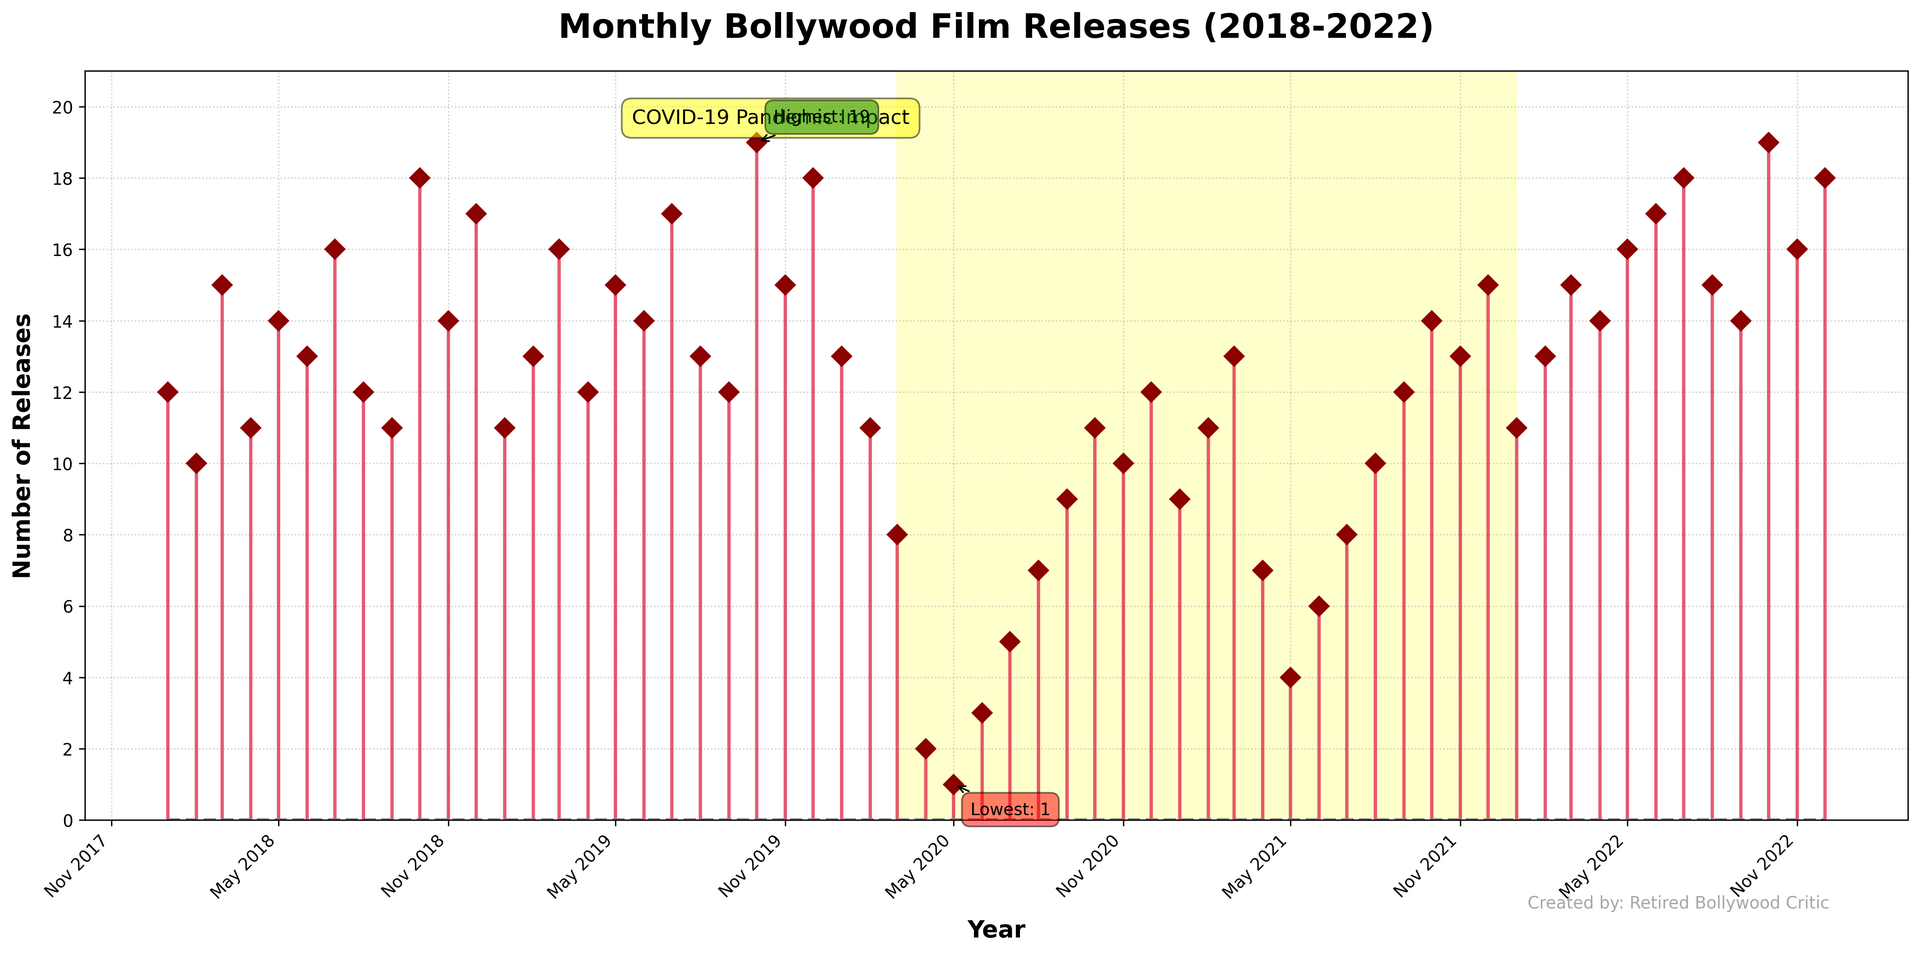What is the highest number of film releases in a single month? The highest number of film releases can be seen clearly marked with an annotation in the figure.
Answer: 19 What month and year had the lowest number of film releases, and what was the count? The figure highlights with an annotation the month with the lowest number of releases, which is indicated at the lowest point on the stem plot.
Answer: May 2020, 1 How did the number of film releases change during the COVID-19 pandemic, and how is this period marked on the plot? The pandemic period is shaded in yellow, and during this time, the number of film releases significantly decreased, especially around early 2020.
Answer: Releases decreased significantly; highlighted in yellow What is the average number of film releases per month in 2018? Sum the number of releases for each month in 2018 and divide by 12. Calculation: (12 + 10 + 15 + 11 + 14 + 13 + 16 + 12 + 11 + 18 + 14 + 17) / 12 = 153 / 12
Answer: 12.75 Describe how the number of film releases trends from 2018 to 2022. Before the pandemic (2018-2019), releases were higher. During the pandemic (2020-2021), releases sharply decreased and then started to recover post-pandemic in 2022.
Answer: High, drop during pandemic, then recovery What is the difference in the number of film releases between October 2019 and October 2020? Refer to the October 2019 and October 2020 data points. October 2019 had 19 releases, and October 2020 had 11 releases. The difference is 19 - 11 = 8.
Answer: 8 Which month consistently had high film releases across the years, and what evidence supports this? July often had high releases, reaching peaks such as 16 in 2018, 17 in 2019, and progressively recovering post-pandemic in 2022 with 18 releases.
Answer: July; consistently high values How does the number of film releases in December 2020 compare to December 2021 and December 2022? Refer to the data points for these three Decembers: 12 in 2020, 15 in 2021, 18 in 2022. The count increased each year.
Answer: December releases increased each year from 2020 to 2022 What visual elements highlight the pandemic's impact on film releases? The plot uses a yellow shaded region and a text box annotation to highlight the pandemic period, showing a clear drop in the number of releases.
Answer: Yellow shaded region and text box How do film releases in November 2022 compare to November 2019? Compare the stem plot markers for these dates: November 2019 had 15 releases, while November 2022 had 16. Thus, November 2022 had one more release than November 2019.
Answer: Slightly higher in November 2022 